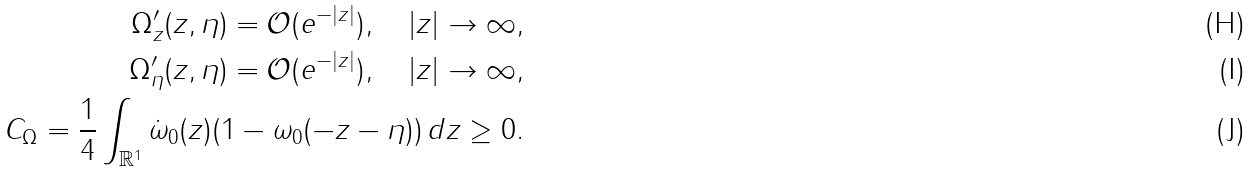Convert formula to latex. <formula><loc_0><loc_0><loc_500><loc_500>\Omega ^ { \prime } _ { z } ( z , \eta ) = \mathcal { O } ( e ^ { - | z | } ) , \quad | z | \to \infty , \\ \Omega ^ { \prime } _ { \eta } ( z , \eta ) = \mathcal { O } ( e ^ { - | z | } ) , \quad | z | \to \infty , \\ C _ { \Omega } = \frac { 1 } { 4 } \int _ { \mathbb { R } ^ { 1 } } \dot { \omega } _ { 0 } ( z ) ( 1 - \omega _ { 0 } ( - z - \eta ) ) \, d z \geq 0 .</formula> 